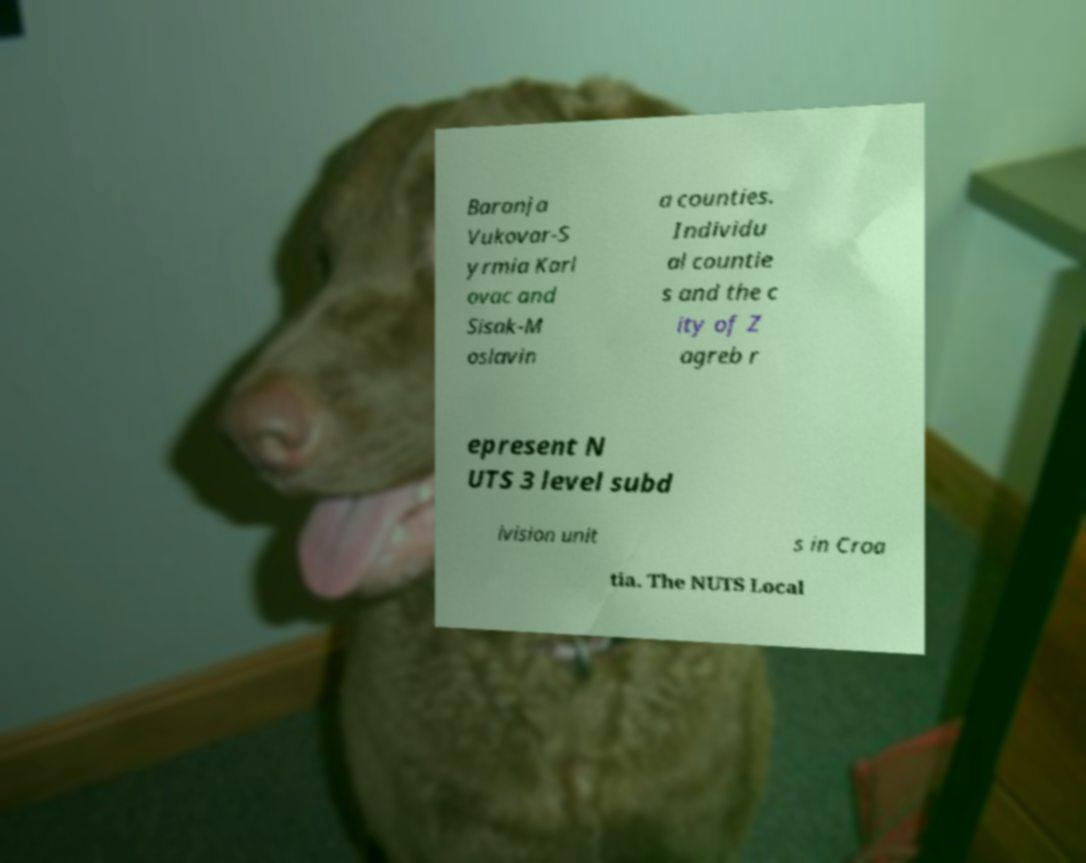What messages or text are displayed in this image? I need them in a readable, typed format. Baranja Vukovar-S yrmia Karl ovac and Sisak-M oslavin a counties. Individu al countie s and the c ity of Z agreb r epresent N UTS 3 level subd ivision unit s in Croa tia. The NUTS Local 